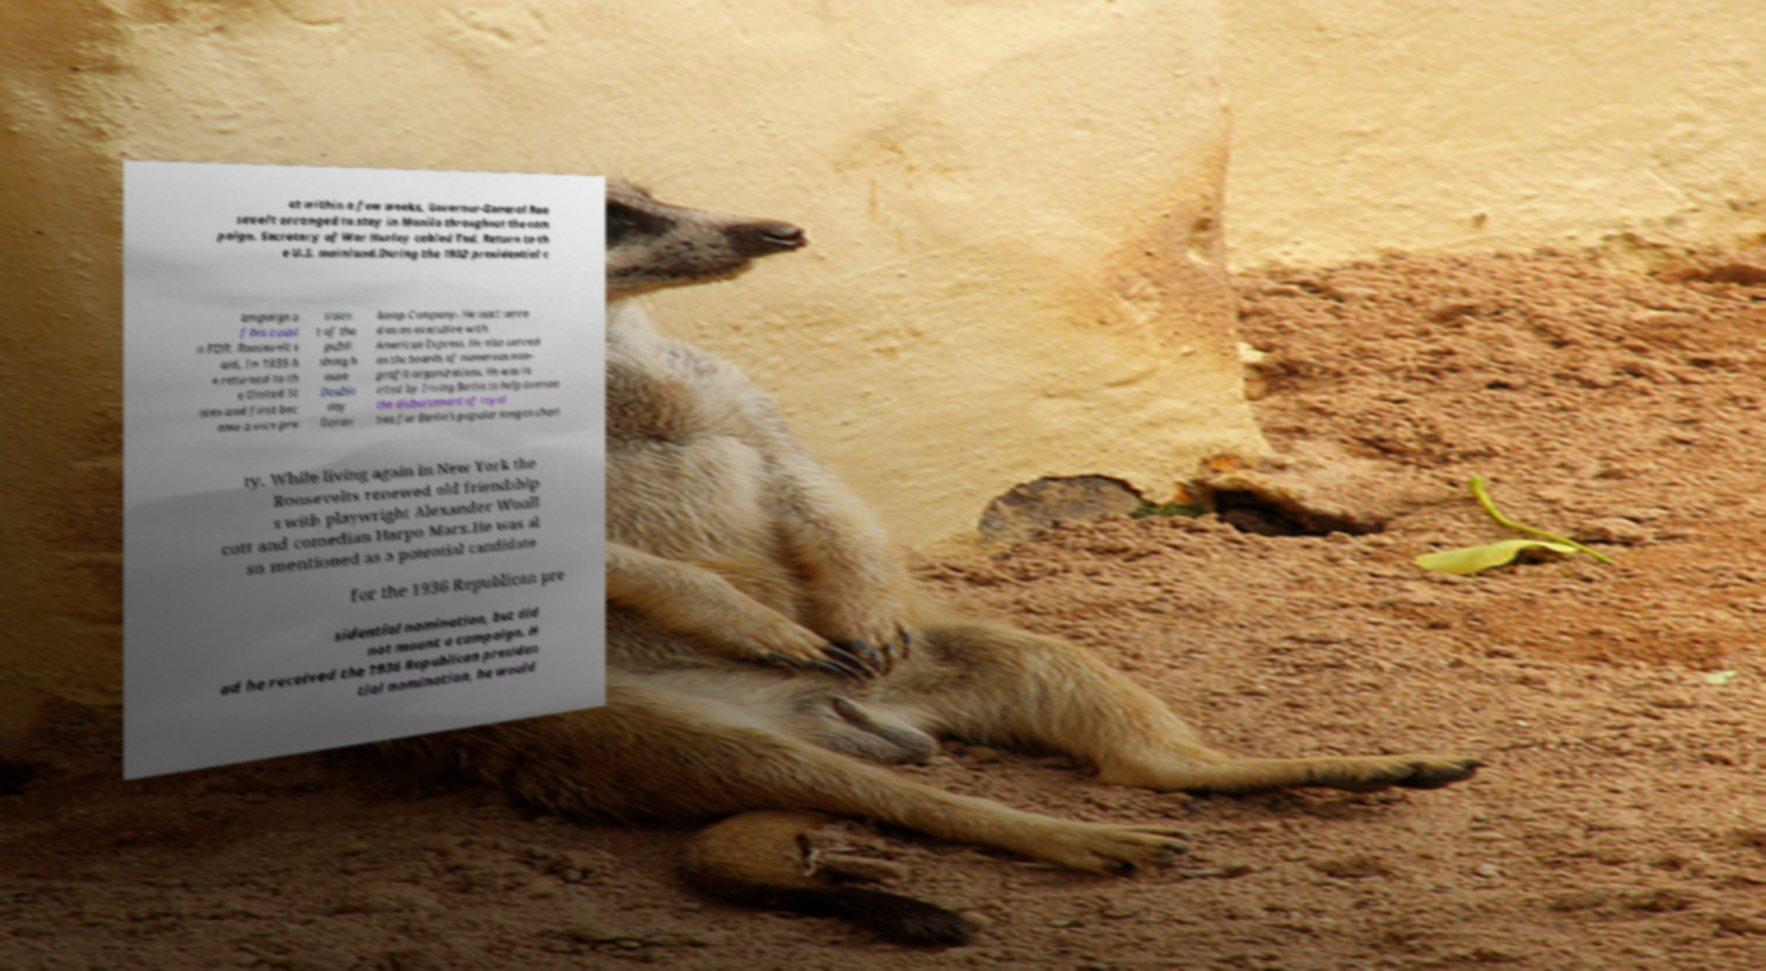Could you extract and type out the text from this image? at within a few weeks, Governor-General Roo sevelt arranged to stay in Manila throughout the cam paign. Secretary of War Hurley cabled Ted, Return to th e U.S. mainland.During the 1932 presidential c ampaign o f his cousi n FDR, Roosevelt s aid, In 1935 h e returned to th e United St ates and first bec ame a vice pre siden t of the publi shing h ouse Double day Doran &amp Company. He next serve d as an executive with American Express. He also served on the boards of numerous non- profit organizations. He was in vited by Irving Berlin to help oversee the disbursement of royal ties for Berlin's popular song to chari ty. While living again in New York the Roosevelts renewed old friendship s with playwright Alexander Wooll cott and comedian Harpo Marx.He was al so mentioned as a potential candidate for the 1936 Republican pre sidential nomination, but did not mount a campaign. H ad he received the 1936 Republican presiden tial nomination, he would 